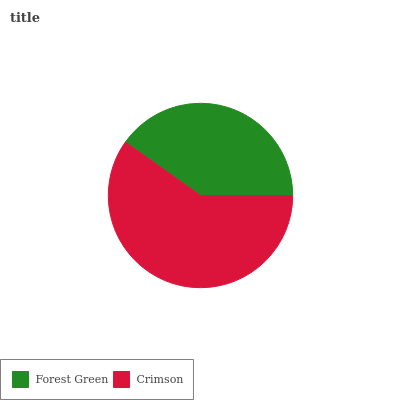Is Forest Green the minimum?
Answer yes or no. Yes. Is Crimson the maximum?
Answer yes or no. Yes. Is Crimson the minimum?
Answer yes or no. No. Is Crimson greater than Forest Green?
Answer yes or no. Yes. Is Forest Green less than Crimson?
Answer yes or no. Yes. Is Forest Green greater than Crimson?
Answer yes or no. No. Is Crimson less than Forest Green?
Answer yes or no. No. Is Crimson the high median?
Answer yes or no. Yes. Is Forest Green the low median?
Answer yes or no. Yes. Is Forest Green the high median?
Answer yes or no. No. Is Crimson the low median?
Answer yes or no. No. 